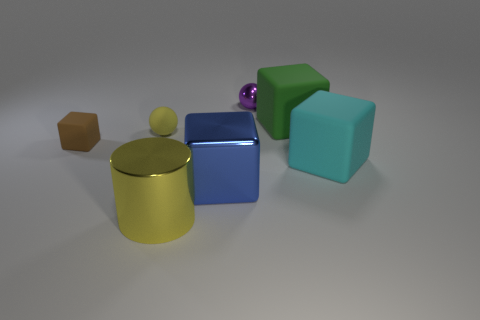Is the shape of the large metal object that is behind the large cylinder the same as the big matte object that is to the right of the green cube?
Keep it short and to the point. Yes. What color is the sphere that is made of the same material as the small brown thing?
Make the answer very short. Yellow. Do the cylinder and the matte ball have the same color?
Your answer should be very brief. Yes. There is a blue shiny object that is the same size as the cyan cube; what is its shape?
Provide a succinct answer. Cube. The matte sphere has what size?
Provide a short and direct response. Small. There is a sphere in front of the small purple metallic thing; is it the same size as the yellow thing in front of the tiny yellow rubber object?
Provide a short and direct response. No. There is a thing that is in front of the large cube in front of the cyan rubber cube; what is its color?
Keep it short and to the point. Yellow. What material is the green thing that is the same size as the blue metallic thing?
Offer a very short reply. Rubber. What number of rubber things are purple things or blocks?
Provide a short and direct response. 3. There is a metallic thing that is both to the right of the large yellow cylinder and in front of the green block; what is its color?
Offer a very short reply. Blue. 